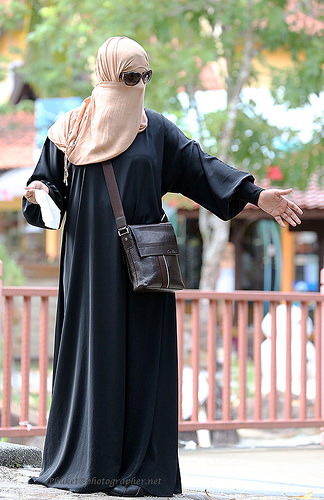<image>
Is there a woman under the tree? No. The woman is not positioned under the tree. The vertical relationship between these objects is different. Is the woman behind the fence? No. The woman is not behind the fence. From this viewpoint, the woman appears to be positioned elsewhere in the scene. 